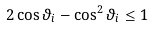Convert formula to latex. <formula><loc_0><loc_0><loc_500><loc_500>2 \cos \vartheta _ { i } - \cos ^ { 2 } \vartheta _ { i } \leq 1</formula> 